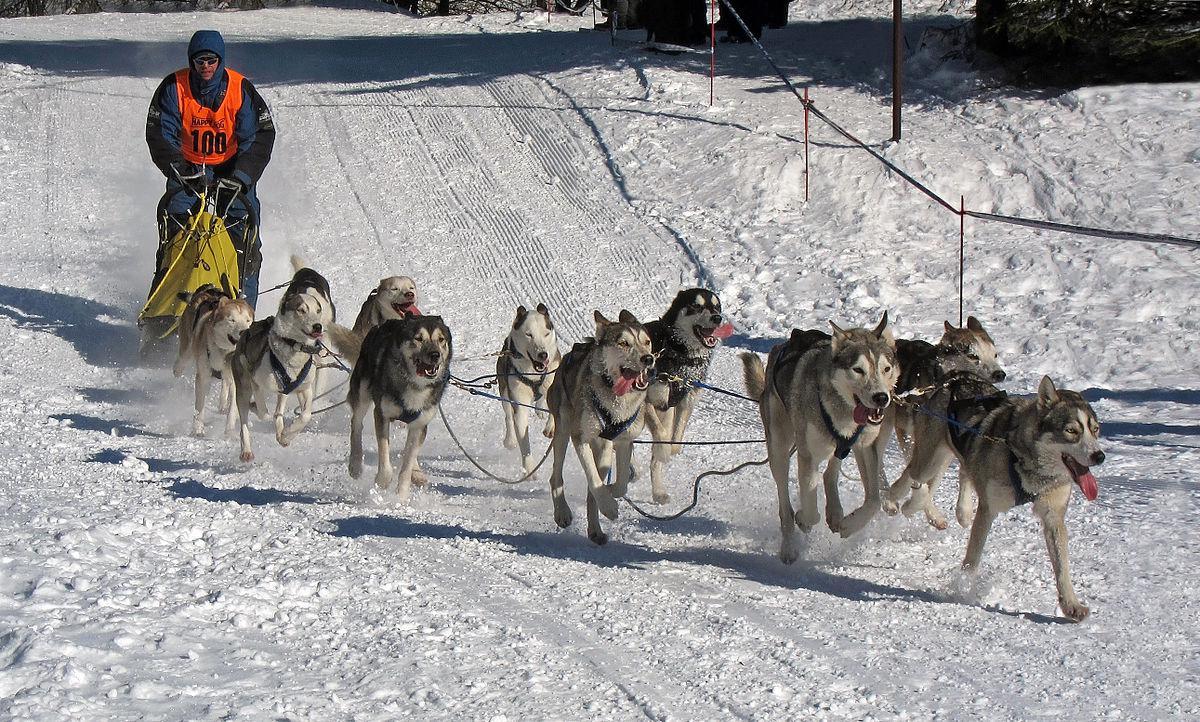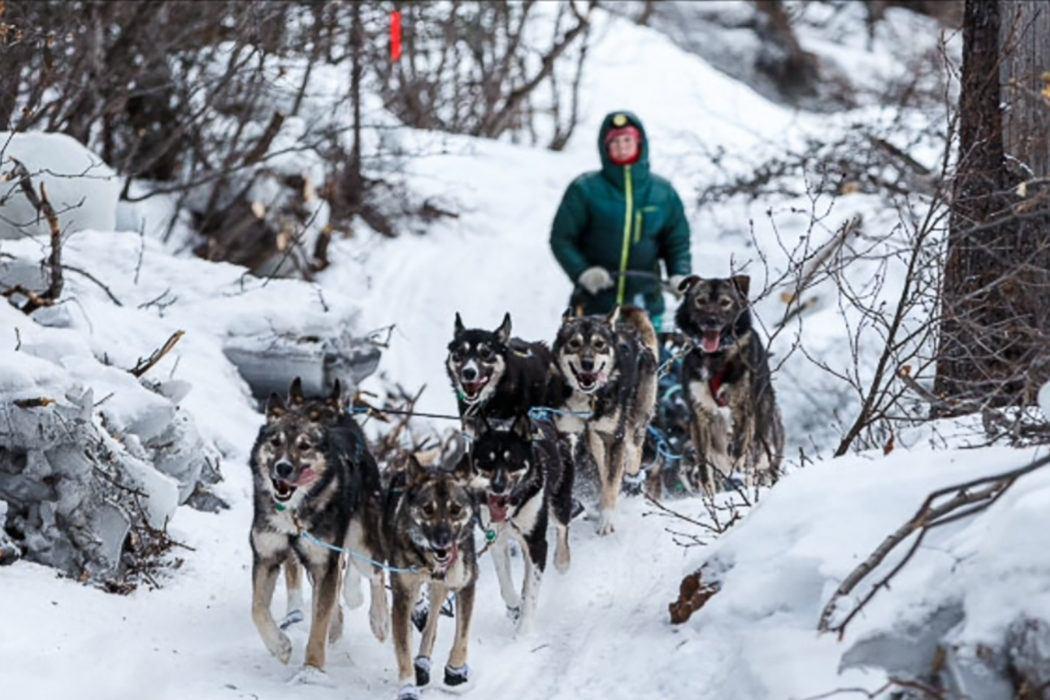The first image is the image on the left, the second image is the image on the right. For the images shown, is this caption "The person driving the sled in the image on the right is wearing a white numbered vest." true? Answer yes or no. No. The first image is the image on the left, the second image is the image on the right. Considering the images on both sides, is "At least one man is riding a sled wearing a white vest that is numbered." valid? Answer yes or no. No. 